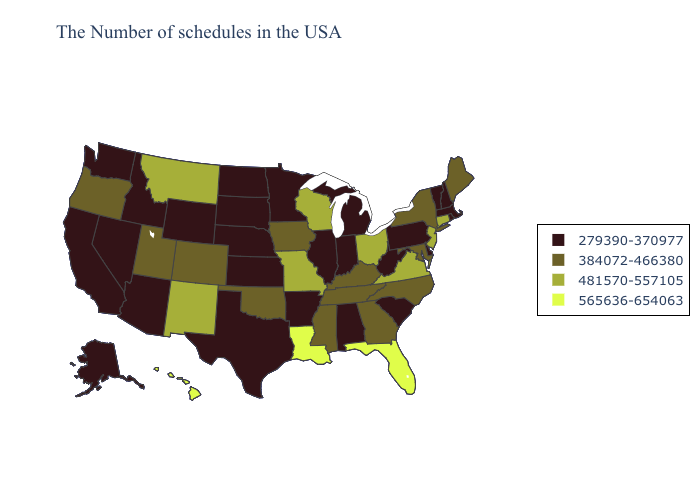Name the states that have a value in the range 384072-466380?
Quick response, please. Maine, New York, Maryland, North Carolina, Georgia, Kentucky, Tennessee, Mississippi, Iowa, Oklahoma, Colorado, Utah, Oregon. Does Pennsylvania have the highest value in the Northeast?
Answer briefly. No. Name the states that have a value in the range 481570-557105?
Keep it brief. Connecticut, New Jersey, Virginia, Ohio, Wisconsin, Missouri, New Mexico, Montana. How many symbols are there in the legend?
Short answer required. 4. Among the states that border Nevada , does Arizona have the highest value?
Be succinct. No. What is the value of Wyoming?
Concise answer only. 279390-370977. Does the map have missing data?
Quick response, please. No. Name the states that have a value in the range 384072-466380?
Keep it brief. Maine, New York, Maryland, North Carolina, Georgia, Kentucky, Tennessee, Mississippi, Iowa, Oklahoma, Colorado, Utah, Oregon. Does Alaska have the highest value in the USA?
Write a very short answer. No. What is the value of West Virginia?
Answer briefly. 279390-370977. Does Alabama have the lowest value in the USA?
Be succinct. Yes. Name the states that have a value in the range 565636-654063?
Concise answer only. Florida, Louisiana, Hawaii. What is the highest value in the West ?
Keep it brief. 565636-654063. Does the map have missing data?
Answer briefly. No. 